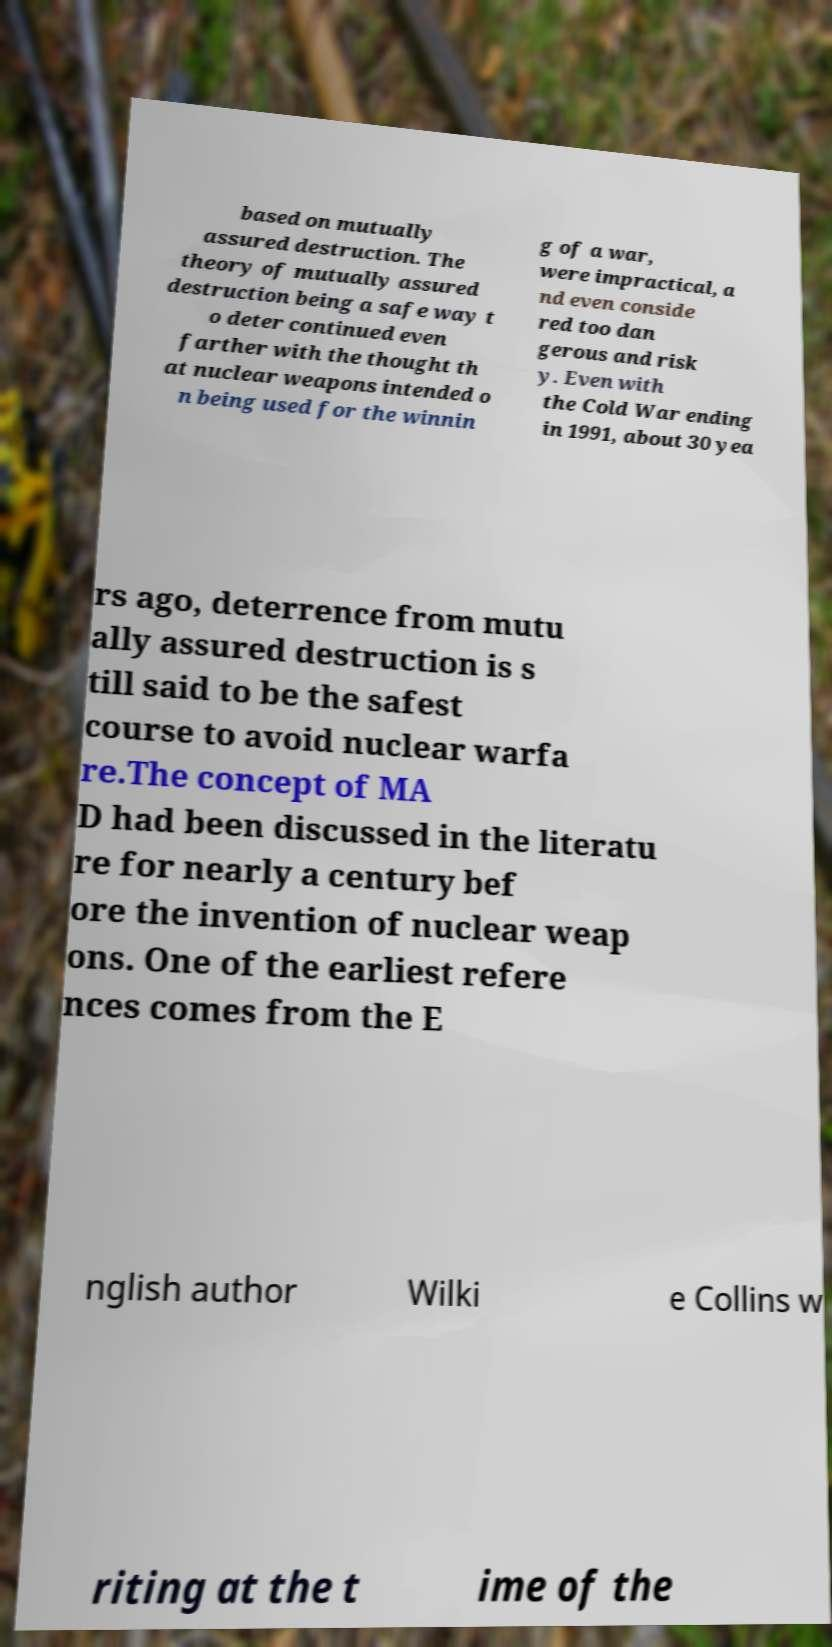For documentation purposes, I need the text within this image transcribed. Could you provide that? based on mutually assured destruction. The theory of mutually assured destruction being a safe way t o deter continued even farther with the thought th at nuclear weapons intended o n being used for the winnin g of a war, were impractical, a nd even conside red too dan gerous and risk y. Even with the Cold War ending in 1991, about 30 yea rs ago, deterrence from mutu ally assured destruction is s till said to be the safest course to avoid nuclear warfa re.The concept of MA D had been discussed in the literatu re for nearly a century bef ore the invention of nuclear weap ons. One of the earliest refere nces comes from the E nglish author Wilki e Collins w riting at the t ime of the 